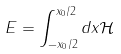<formula> <loc_0><loc_0><loc_500><loc_500>E = \int _ { - x _ { 0 } / 2 } ^ { x _ { 0 } / 2 } d x \mathcal { H }</formula> 